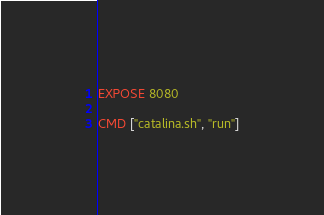Convert code to text. <code><loc_0><loc_0><loc_500><loc_500><_Dockerfile_>
EXPOSE 8080

CMD ["catalina.sh", "run"]
</code> 